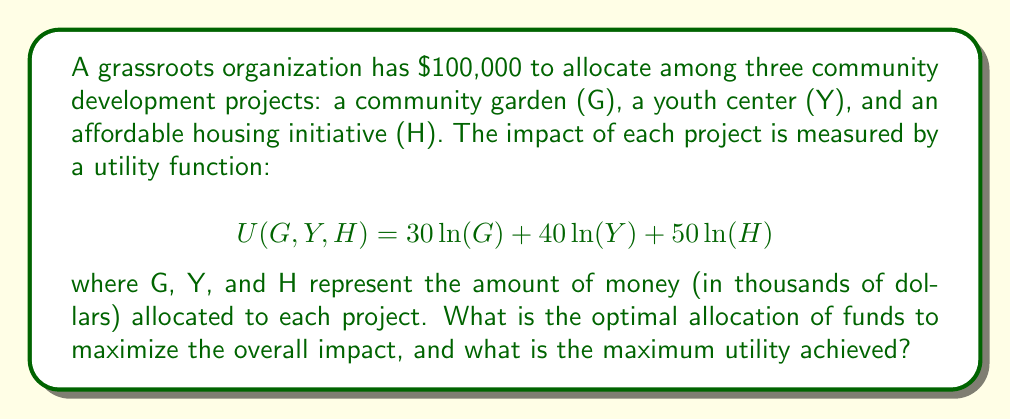Could you help me with this problem? To solve this optimization problem, we'll use the method of Lagrange multipliers:

1) First, we set up the constraint equation:
   $$G + Y + H = 100$$

2) Now, we form the Lagrangian function:
   $$L(G,Y,H,\lambda) = 30\ln(G) + 40\ln(Y) + 50\ln(H) - \lambda(G + Y + H - 100)$$

3) We take partial derivatives and set them equal to zero:
   $$\frac{\partial L}{\partial G} = \frac{30}{G} - \lambda = 0$$
   $$\frac{\partial L}{\partial Y} = \frac{40}{Y} - \lambda = 0$$
   $$\frac{\partial L}{\partial H} = \frac{50}{H} - \lambda = 0$$
   $$\frac{\partial L}{\partial \lambda} = G + Y + H - 100 = 0$$

4) From the first three equations:
   $$G = \frac{30}{\lambda}, Y = \frac{40}{\lambda}, H = \frac{50}{\lambda}$$

5) Substituting these into the constraint equation:
   $$\frac{30}{\lambda} + \frac{40}{\lambda} + \frac{50}{\lambda} = 100$$
   $$\frac{120}{\lambda} = 100$$
   $$\lambda = 1.2$$

6) Now we can solve for G, Y, and H:
   $$G = \frac{30}{1.2} = 25$$
   $$Y = \frac{40}{1.2} = 33.33$$
   $$H = \frac{50}{1.2} = 41.67$$

7) To find the maximum utility, we substitute these values into the original utility function:
   $$U(25,33.33,41.67) = 30\ln(25) + 40\ln(33.33) + 50\ln(41.67)$$
Answer: The optimal allocation is:
Community Garden (G): $25,000
Youth Center (Y): $33,333
Affordable Housing (H): $41,667

The maximum utility achieved is approximately 461.47. 